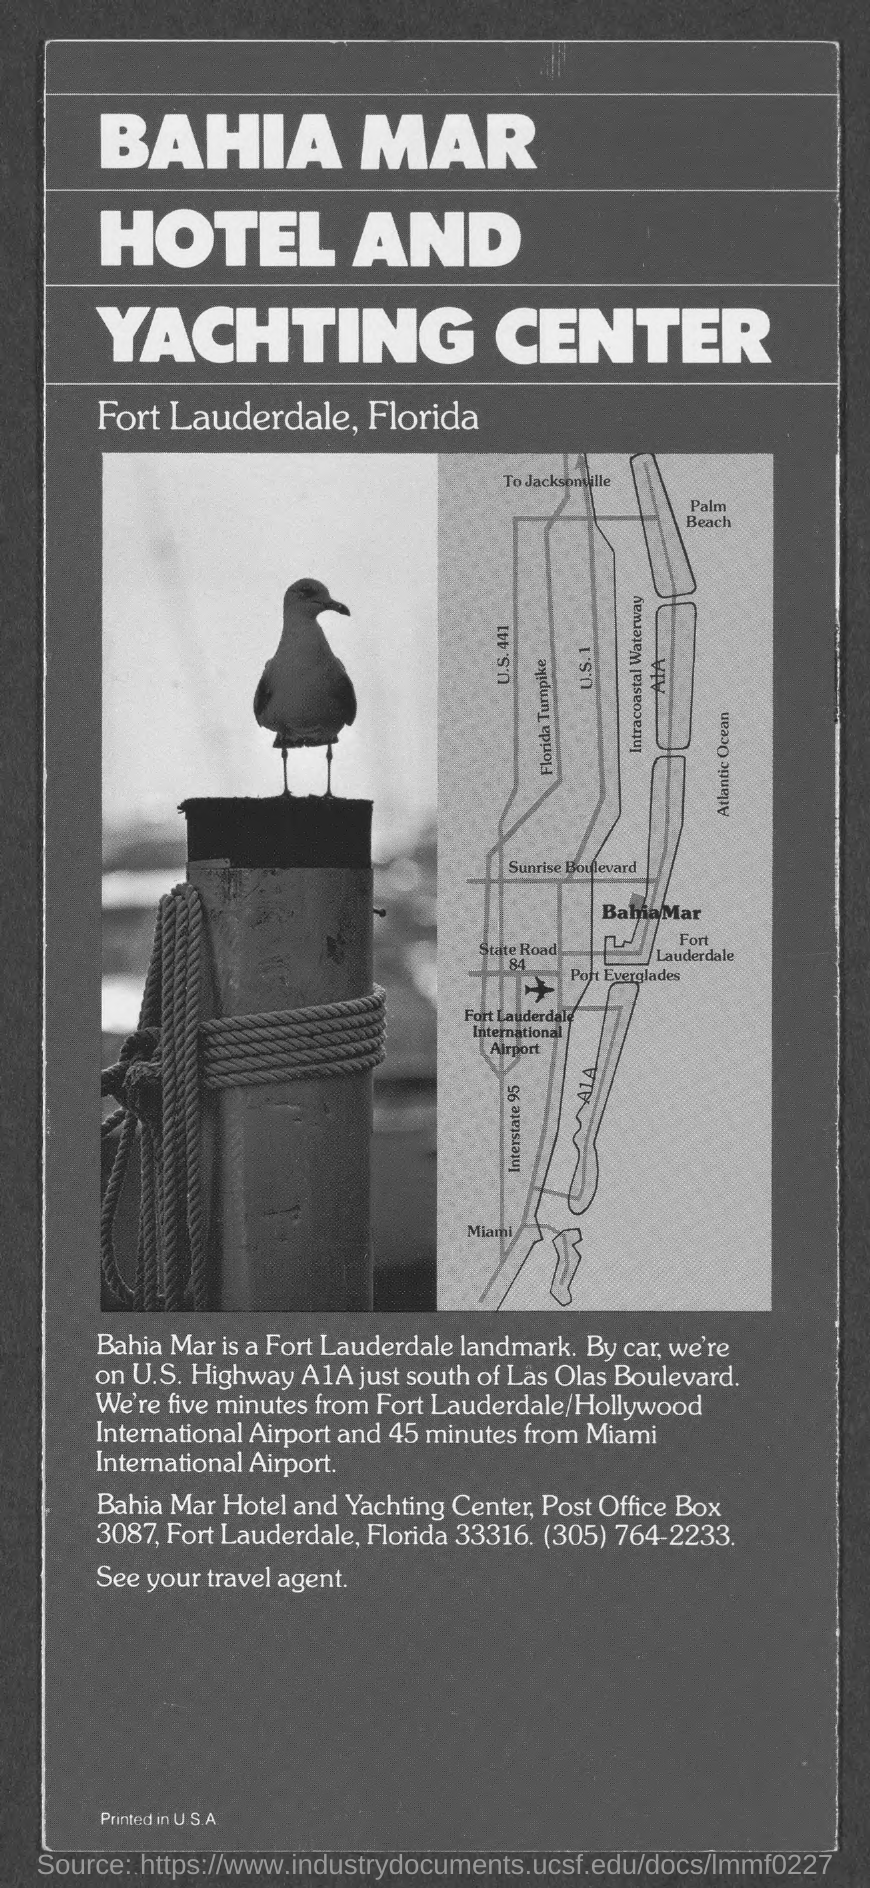How far is it from MIami International Airport?
Make the answer very short. 45 minutes. How far is it from Fort Lauderdale/Hollywood International Airport?
Your answer should be very brief. Five minutes. It is south of what?
Give a very brief answer. LAS OLAS BOULEVARD. 